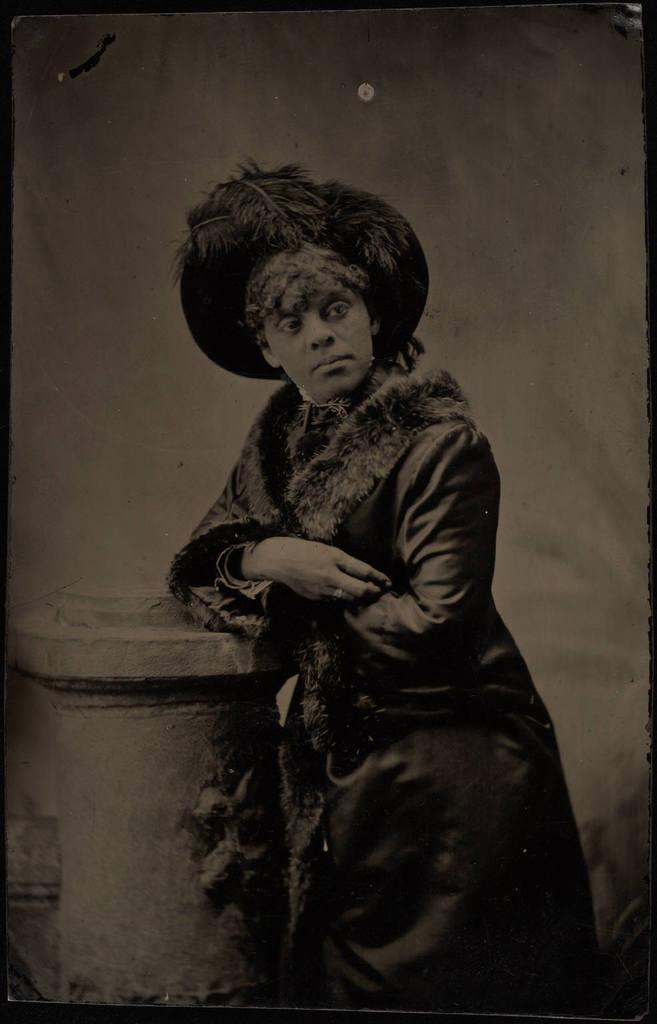What is the color scheme of the image? The image is black and white. What can be seen in the foreground of the image? There is a person standing in front of a concrete building. What is visible in the background of the image? There is a wall in the background of the image. How many friends is the person combing their hair with in the image? There is no friend or combing activity present in the image. 